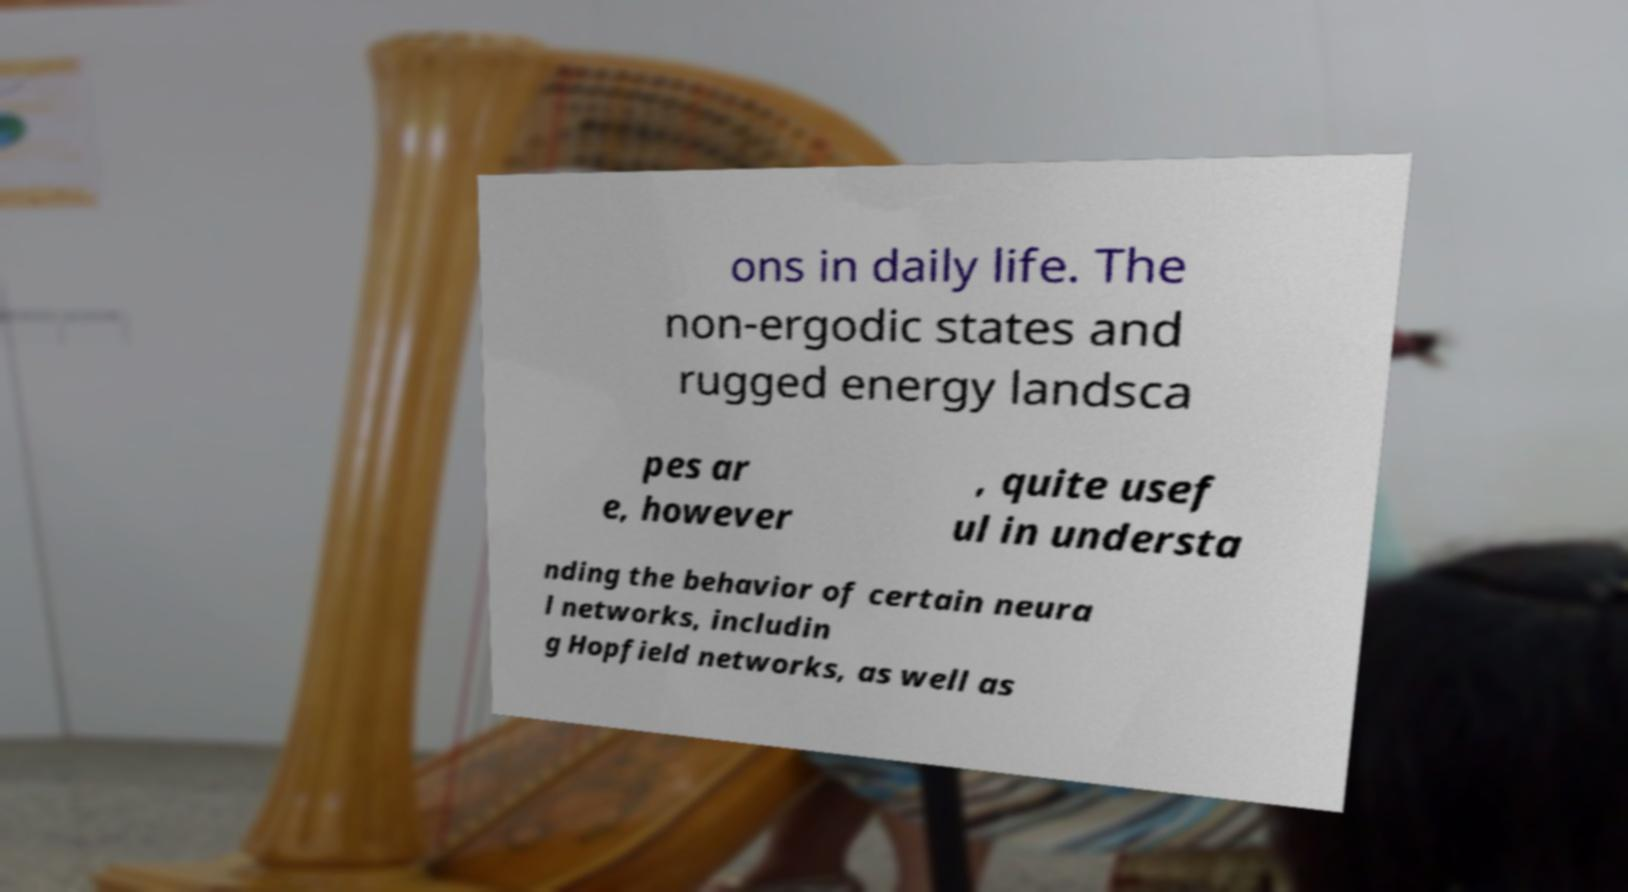Can you accurately transcribe the text from the provided image for me? ons in daily life. The non-ergodic states and rugged energy landsca pes ar e, however , quite usef ul in understa nding the behavior of certain neura l networks, includin g Hopfield networks, as well as 